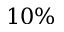<formula> <loc_0><loc_0><loc_500><loc_500>1 0 \%</formula> 